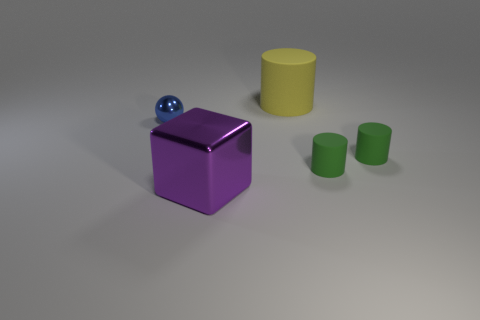What number of big things are cyan objects or purple metallic objects?
Provide a short and direct response. 1. Does the large thing in front of the sphere have the same material as the ball?
Offer a terse response. Yes. What shape is the large object in front of the small object left of the big thing that is to the right of the purple cube?
Keep it short and to the point. Cube. What number of purple objects are either big blocks or small balls?
Ensure brevity in your answer.  1. Is the number of metal cubes that are left of the small metal sphere the same as the number of small things on the left side of the metal cube?
Offer a very short reply. No. Are there any other things that have the same shape as the purple metal object?
Give a very brief answer. No. The big object that is made of the same material as the tiny blue object is what shape?
Provide a short and direct response. Cube. Are there an equal number of yellow matte cylinders in front of the metal ball and large gray balls?
Keep it short and to the point. Yes. Does the thing on the left side of the purple metal block have the same material as the cylinder behind the blue sphere?
Offer a very short reply. No. The big thing that is behind the metal thing on the right side of the blue shiny object is what shape?
Keep it short and to the point. Cylinder. 